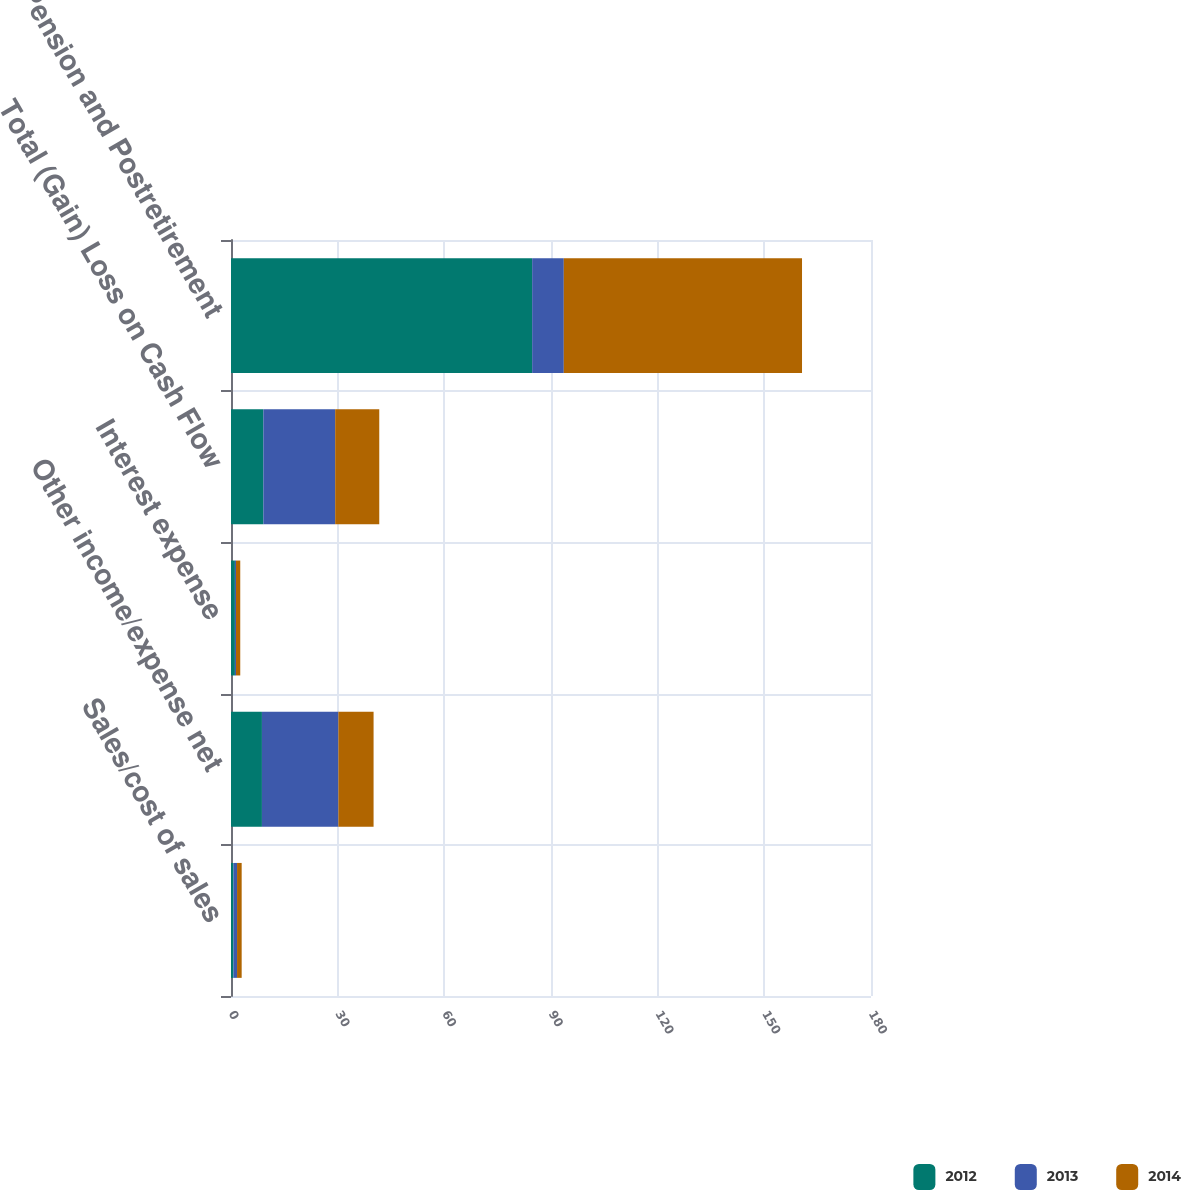Convert chart. <chart><loc_0><loc_0><loc_500><loc_500><stacked_bar_chart><ecel><fcel>Sales/cost of sales<fcel>Other income/expense net<fcel>Interest expense<fcel>Total (Gain) Loss on Cash Flow<fcel>Pension and Postretirement<nl><fcel>2012<fcel>0.7<fcel>8.7<fcel>1.1<fcel>9.1<fcel>84.7<nl><fcel>2013<fcel>1<fcel>21.5<fcel>0.3<fcel>20.2<fcel>8.9<nl><fcel>2014<fcel>1.3<fcel>9.9<fcel>1.2<fcel>12.4<fcel>67<nl></chart> 